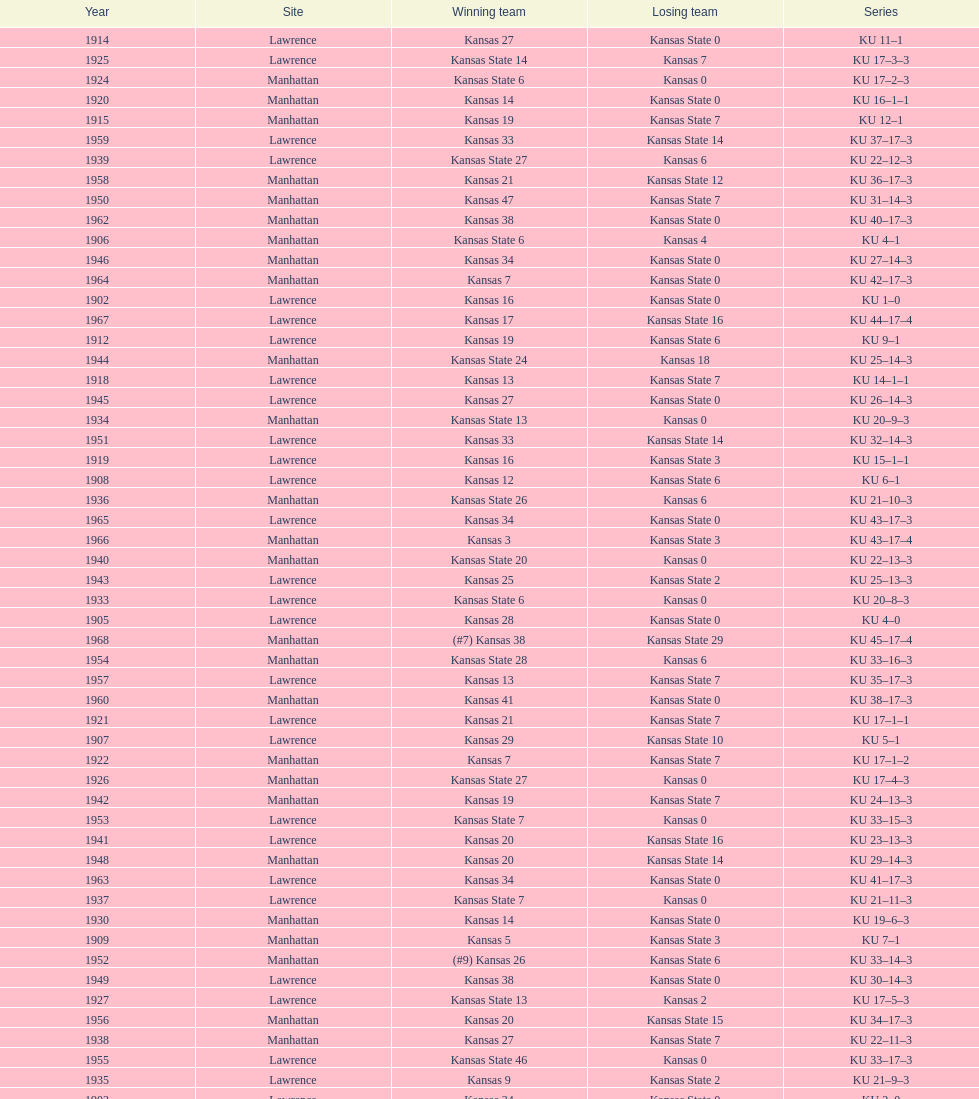How many times did kansas beat kansas state before 1910? 7. 